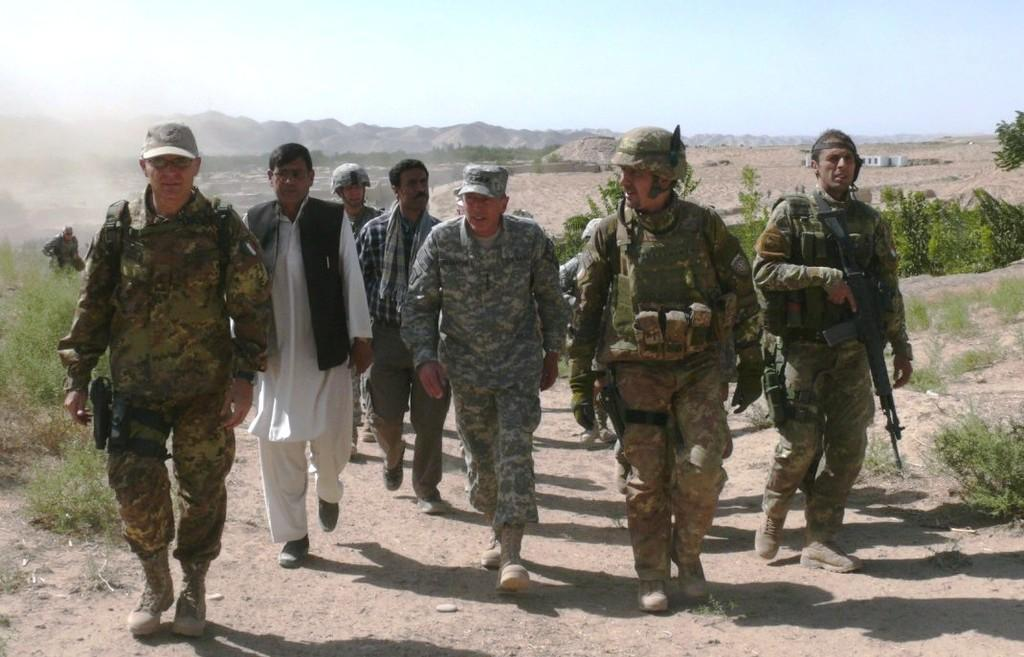How many people are in the image? There is a group of people in the image. What are the people doing in the image? The people are walking through a walkway. What can be seen in the image besides the people? There are plants, the ground, trees, houses, hills, and the sky visible in the image. What type of wax is being used to create the tree in the image? There is no tree made of wax in the image; it features real trees in the background. Can you tell me how many volleyballs are being played with in the image? There is no volleyball present in the image. 